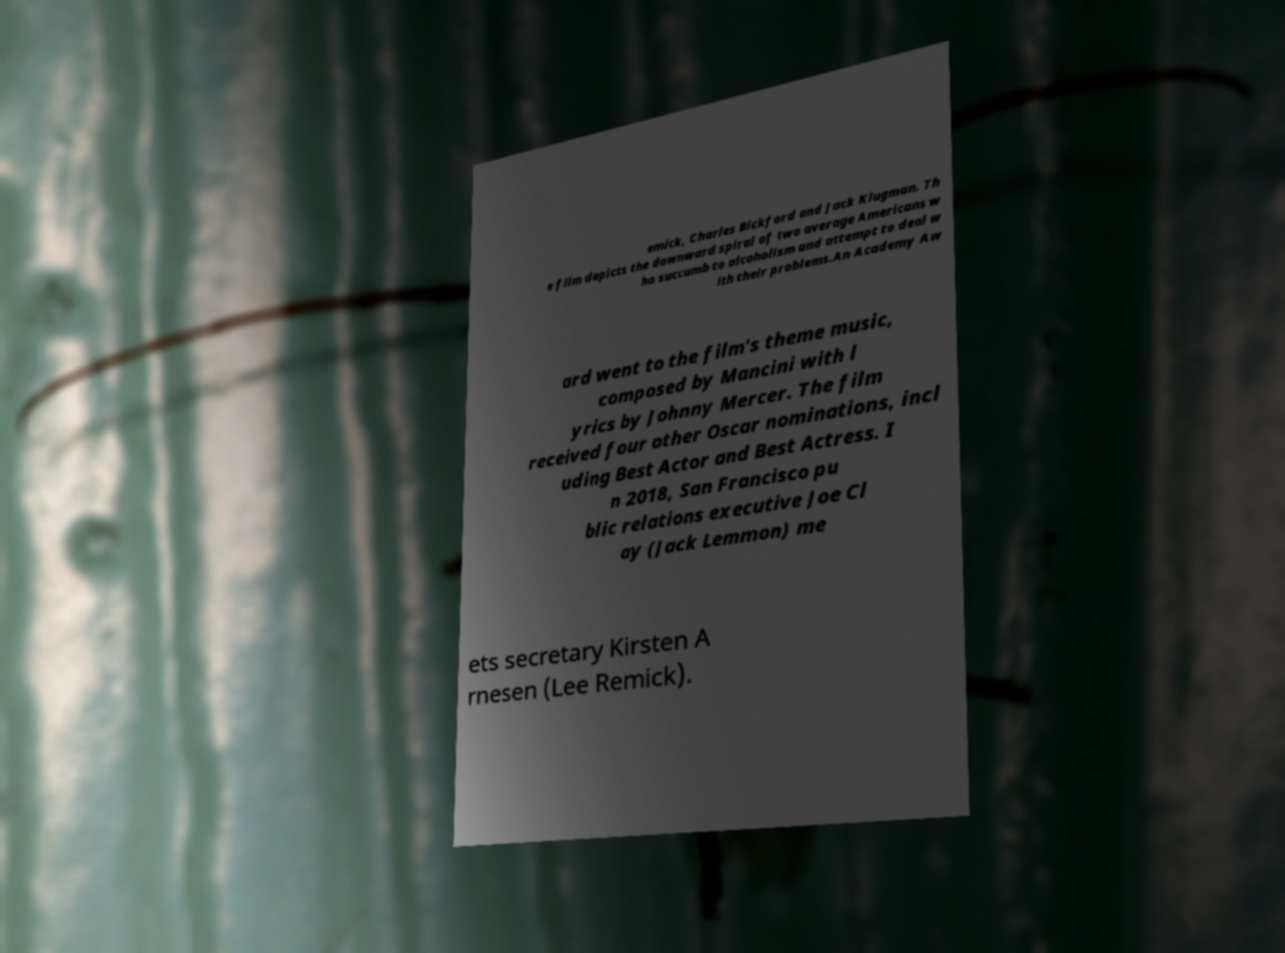Please identify and transcribe the text found in this image. emick, Charles Bickford and Jack Klugman. Th e film depicts the downward spiral of two average Americans w ho succumb to alcoholism and attempt to deal w ith their problems.An Academy Aw ard went to the film's theme music, composed by Mancini with l yrics by Johnny Mercer. The film received four other Oscar nominations, incl uding Best Actor and Best Actress. I n 2018, San Francisco pu blic relations executive Joe Cl ay (Jack Lemmon) me ets secretary Kirsten A rnesen (Lee Remick). 